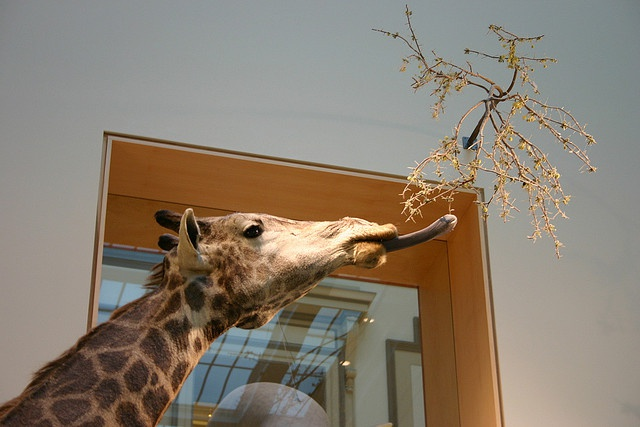Describe the objects in this image and their specific colors. I can see a giraffe in gray, maroon, and black tones in this image. 